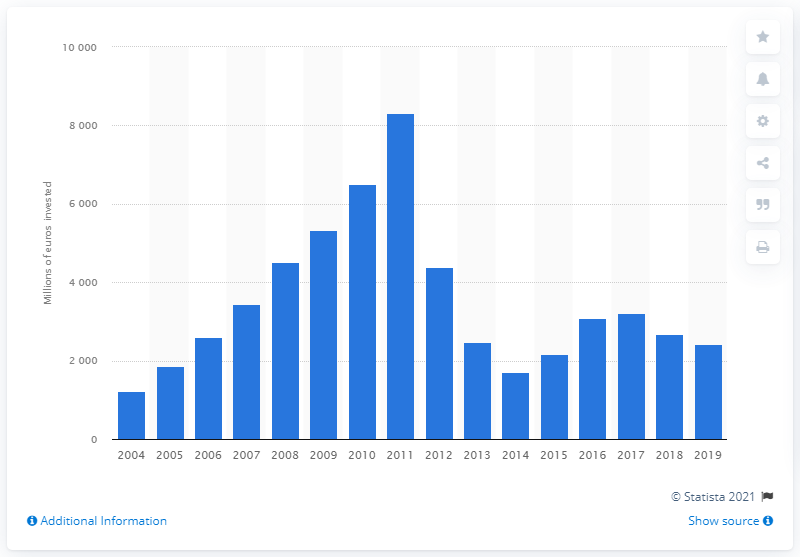Point out several critical features in this image. In 2011, the total investment in road transport infrastructure was 8,319.4. The total investment in Poland's road transport infrastructure in 2019 was 2415.4 million dollars. 